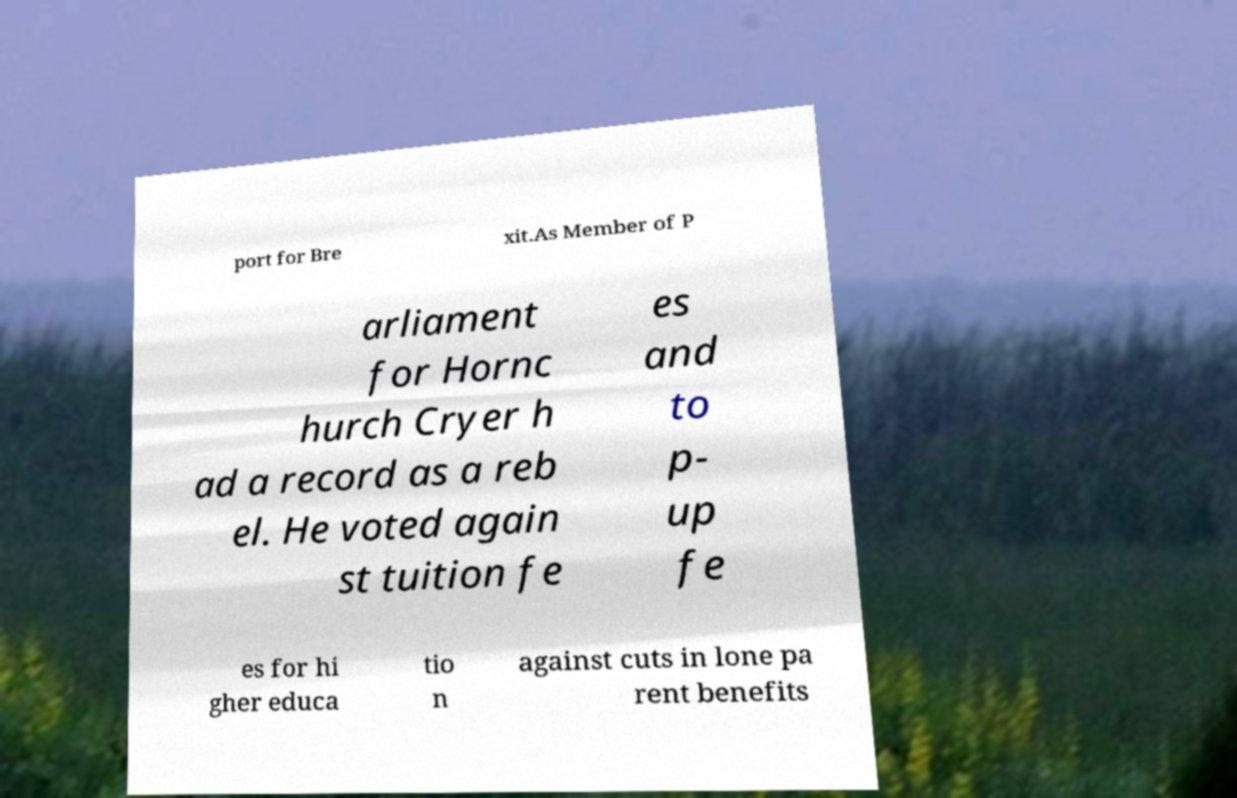Could you extract and type out the text from this image? port for Bre xit.As Member of P arliament for Hornc hurch Cryer h ad a record as a reb el. He voted again st tuition fe es and to p- up fe es for hi gher educa tio n against cuts in lone pa rent benefits 